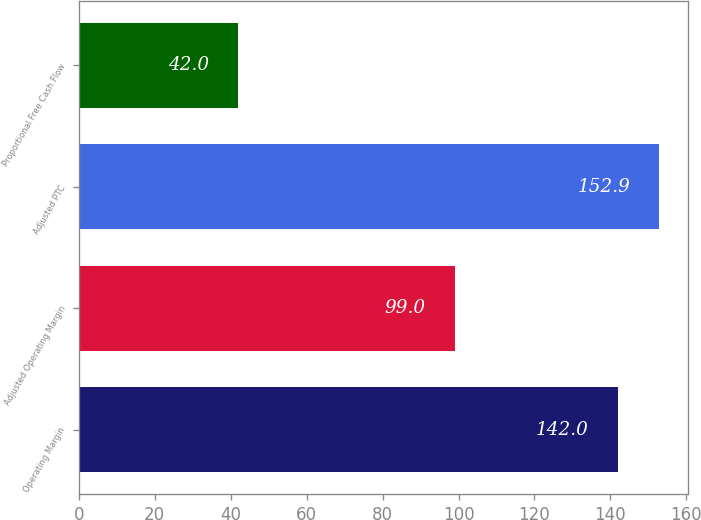Convert chart. <chart><loc_0><loc_0><loc_500><loc_500><bar_chart><fcel>Operating Margin<fcel>Adjusted Operating Margin<fcel>Adjusted PTC<fcel>Proportional Free Cash Flow<nl><fcel>142<fcel>99<fcel>152.9<fcel>42<nl></chart> 